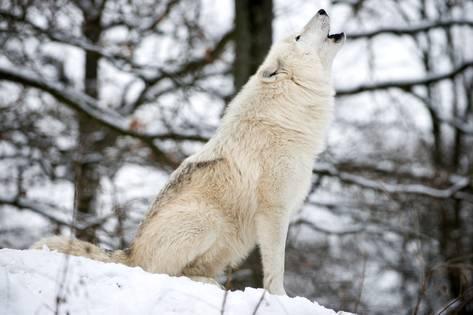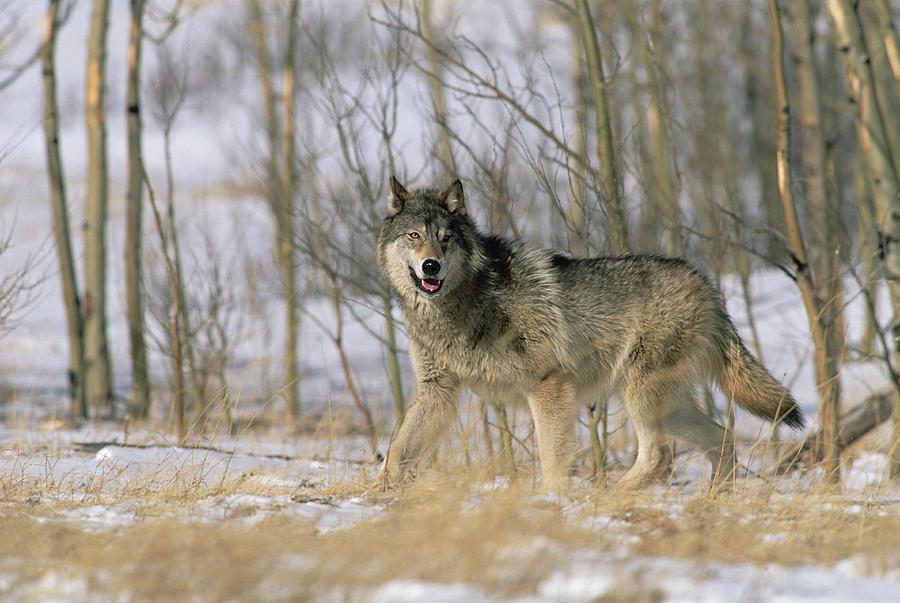The first image is the image on the left, the second image is the image on the right. Considering the images on both sides, is "An image shows one wolf resting on the snow with front paws extended forward." valid? Answer yes or no. No. 